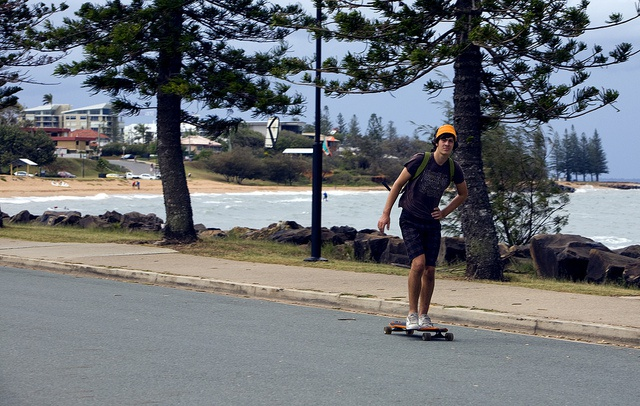Describe the objects in this image and their specific colors. I can see people in black, maroon, and gray tones, skateboard in black and gray tones, backpack in black, darkgreen, and gray tones, umbrella in black, white, gray, and navy tones, and kite in black, lightpink, brown, and teal tones in this image. 